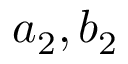<formula> <loc_0><loc_0><loc_500><loc_500>a _ { 2 } , b _ { 2 }</formula> 